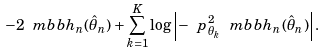Convert formula to latex. <formula><loc_0><loc_0><loc_500><loc_500>- 2 \ m b b h _ { n } ( \hat { \theta } _ { n } ) + \sum _ { k = 1 } ^ { K } \log \left | - \ p _ { \theta _ { k } } ^ { 2 } \ m b b h _ { n } ( \hat { \theta } _ { n } ) \right | .</formula> 